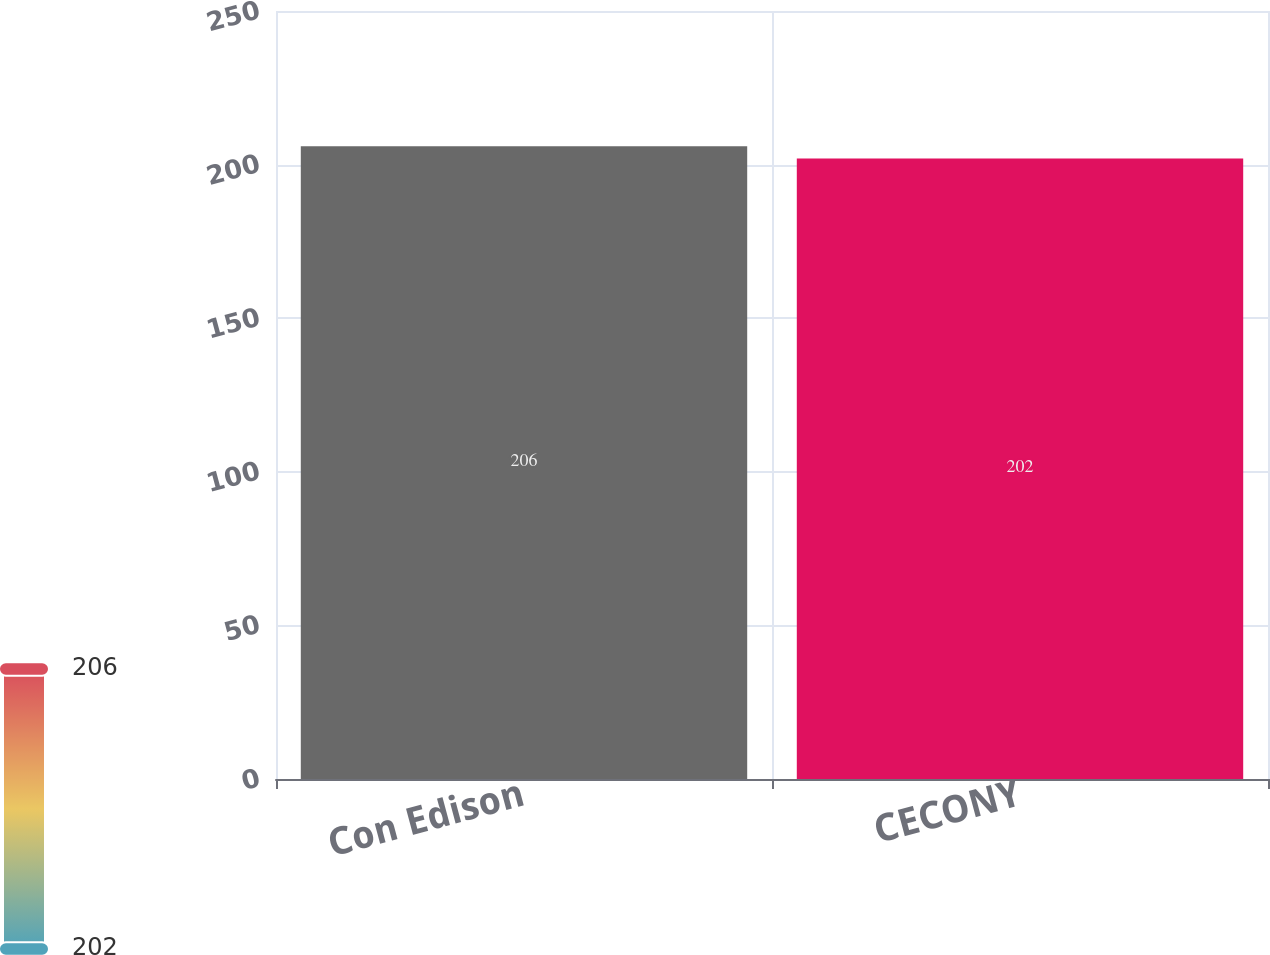<chart> <loc_0><loc_0><loc_500><loc_500><bar_chart><fcel>Con Edison<fcel>CECONY<nl><fcel>206<fcel>202<nl></chart> 